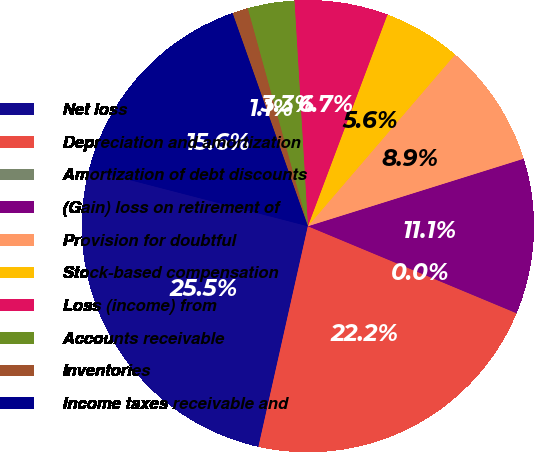Convert chart to OTSL. <chart><loc_0><loc_0><loc_500><loc_500><pie_chart><fcel>Net loss<fcel>Depreciation and amortization<fcel>Amortization of debt discounts<fcel>(Gain) loss on retirement of<fcel>Provision for doubtful<fcel>Stock-based compensation<fcel>Loss (income) from<fcel>Accounts receivable<fcel>Inventories<fcel>Income taxes receivable and<nl><fcel>25.53%<fcel>22.21%<fcel>0.01%<fcel>11.11%<fcel>8.89%<fcel>5.56%<fcel>6.67%<fcel>3.34%<fcel>1.12%<fcel>15.55%<nl></chart> 